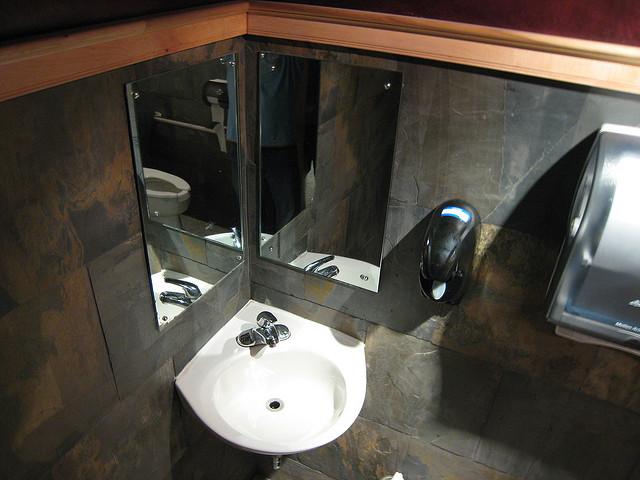What color is the soap dispenser?
Quick response, please. Black. How many mirrors are there?
Be succinct. 2. Where is the sink?
Answer briefly. Corner. 